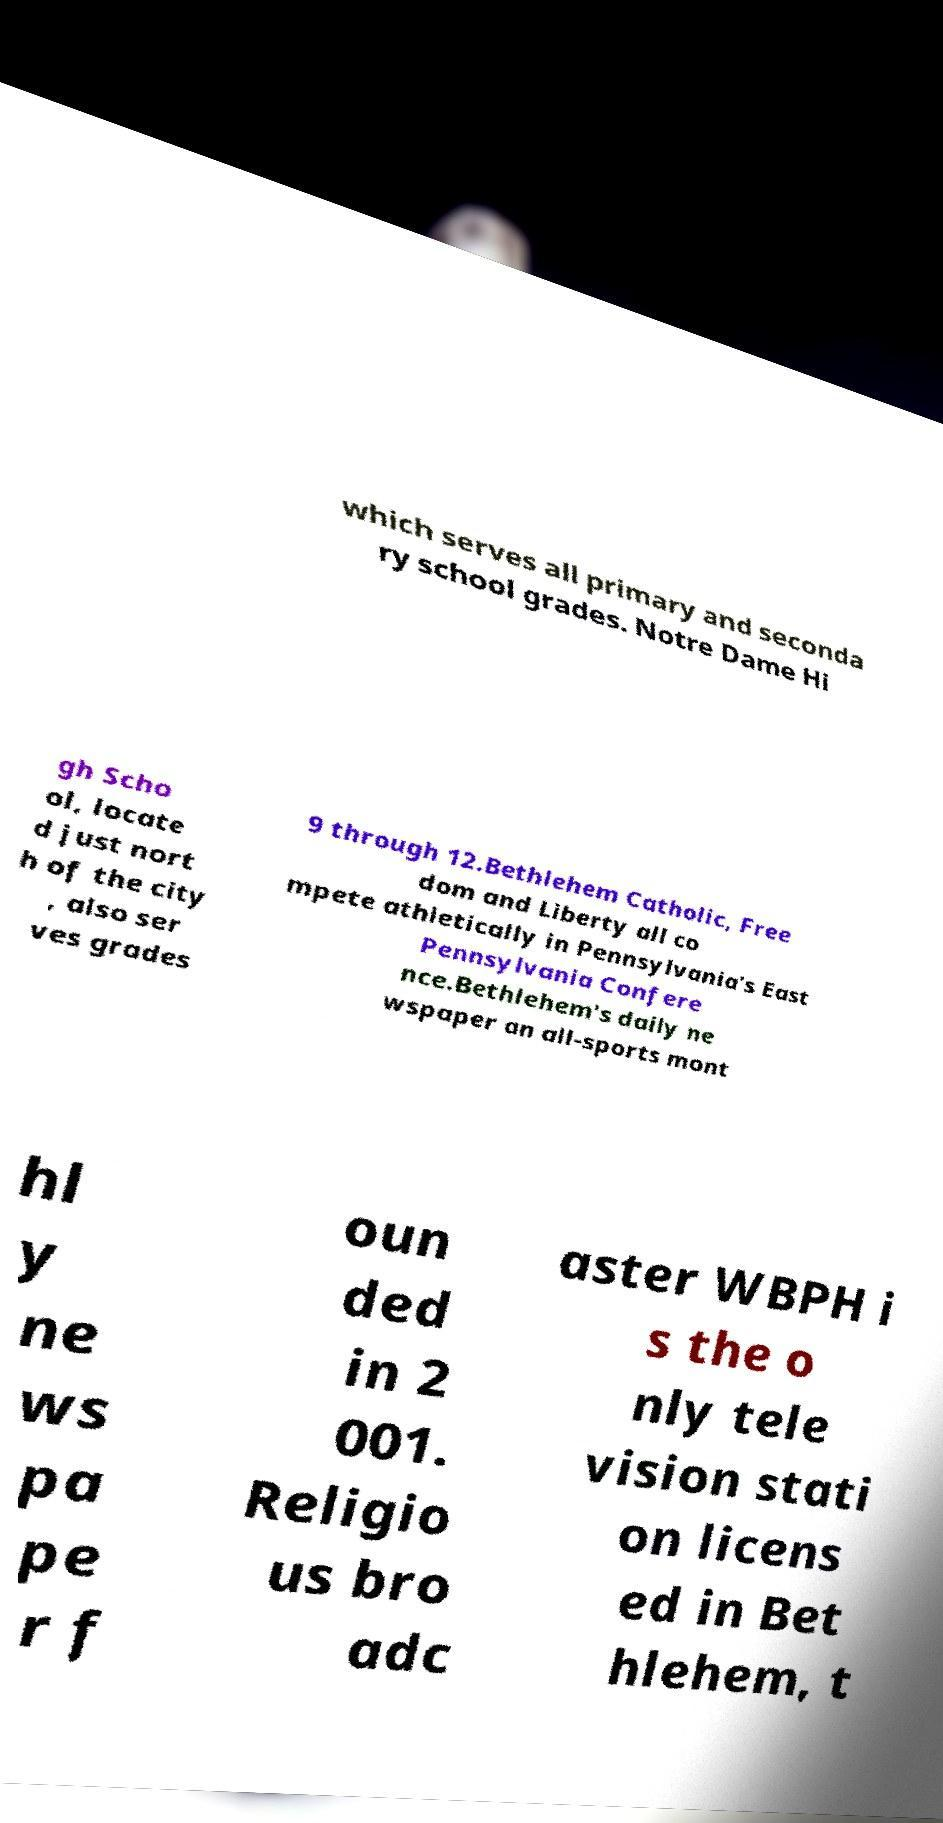Can you read and provide the text displayed in the image?This photo seems to have some interesting text. Can you extract and type it out for me? which serves all primary and seconda ry school grades. Notre Dame Hi gh Scho ol, locate d just nort h of the city , also ser ves grades 9 through 12.Bethlehem Catholic, Free dom and Liberty all co mpete athletically in Pennsylvania's East Pennsylvania Confere nce.Bethlehem's daily ne wspaper an all-sports mont hl y ne ws pa pe r f oun ded in 2 001. Religio us bro adc aster WBPH i s the o nly tele vision stati on licens ed in Bet hlehem, t 